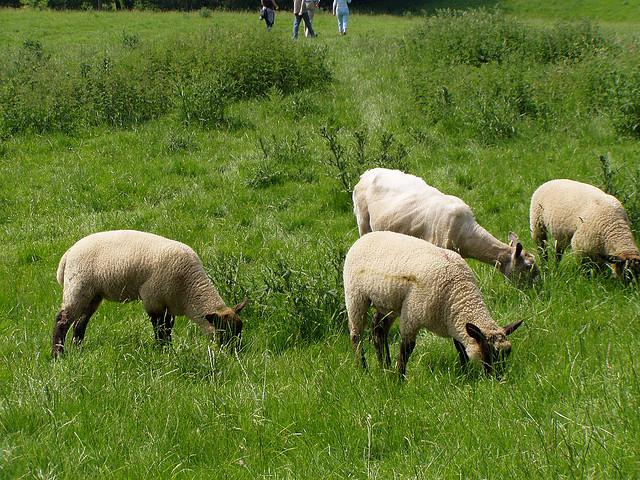How many species are in this image?

Choices:
A) seven
B) two
C) three
D) five two 